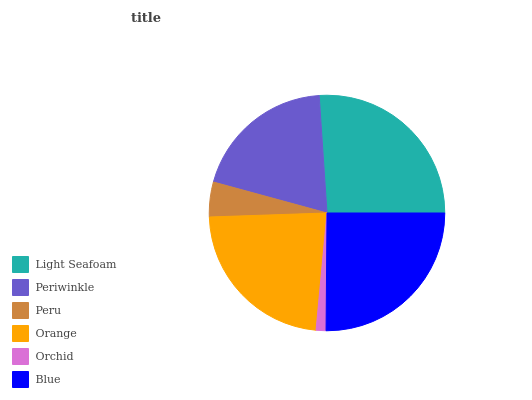Is Orchid the minimum?
Answer yes or no. Yes. Is Light Seafoam the maximum?
Answer yes or no. Yes. Is Periwinkle the minimum?
Answer yes or no. No. Is Periwinkle the maximum?
Answer yes or no. No. Is Light Seafoam greater than Periwinkle?
Answer yes or no. Yes. Is Periwinkle less than Light Seafoam?
Answer yes or no. Yes. Is Periwinkle greater than Light Seafoam?
Answer yes or no. No. Is Light Seafoam less than Periwinkle?
Answer yes or no. No. Is Orange the high median?
Answer yes or no. Yes. Is Periwinkle the low median?
Answer yes or no. Yes. Is Blue the high median?
Answer yes or no. No. Is Orange the low median?
Answer yes or no. No. 